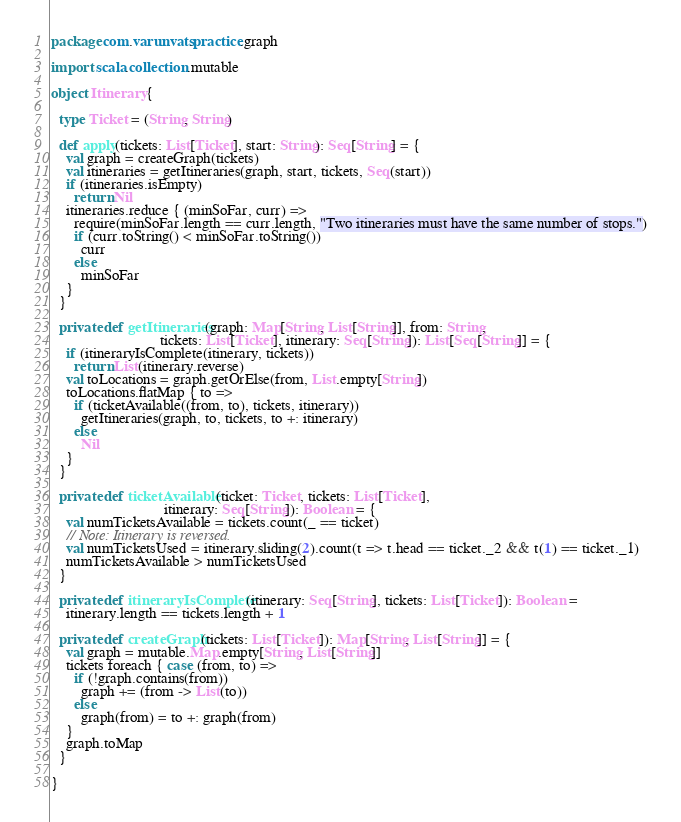Convert code to text. <code><loc_0><loc_0><loc_500><loc_500><_Scala_>package com.varunvats.practice.graph

import scala.collection.mutable

object Itinerary {

  type Ticket = (String, String)

  def apply(tickets: List[Ticket], start: String): Seq[String] = {
    val graph = createGraph(tickets)
    val itineraries = getItineraries(graph, start, tickets, Seq(start))
    if (itineraries.isEmpty)
      return Nil
    itineraries.reduce { (minSoFar, curr) =>
      require(minSoFar.length == curr.length, "Two itineraries must have the same number of stops.")
      if (curr.toString() < minSoFar.toString())
        curr
      else
        minSoFar
    }
  }

  private def getItineraries(graph: Map[String, List[String]], from: String,
                             tickets: List[Ticket], itinerary: Seq[String]): List[Seq[String]] = {
    if (itineraryIsComplete(itinerary, tickets))
      return List(itinerary.reverse)
    val toLocations = graph.getOrElse(from, List.empty[String])
    toLocations.flatMap { to =>
      if (ticketAvailable((from, to), tickets, itinerary))
        getItineraries(graph, to, tickets, to +: itinerary)
      else
        Nil
    }
  }

  private def ticketAvailable(ticket: Ticket, tickets: List[Ticket],
                              itinerary: Seq[String]): Boolean = {
    val numTicketsAvailable = tickets.count(_ == ticket)
    // Note: Itinerary is reversed.
    val numTicketsUsed = itinerary.sliding(2).count(t => t.head == ticket._2 && t(1) == ticket._1)
    numTicketsAvailable > numTicketsUsed
  }

  private def itineraryIsComplete(itinerary: Seq[String], tickets: List[Ticket]): Boolean =
    itinerary.length == tickets.length + 1

  private def createGraph(tickets: List[Ticket]): Map[String, List[String]] = {
    val graph = mutable.Map.empty[String, List[String]]
    tickets foreach { case (from, to) =>
      if (!graph.contains(from))
        graph += (from -> List(to))
      else
        graph(from) = to +: graph(from)
    }
    graph.toMap
  }

}
</code> 